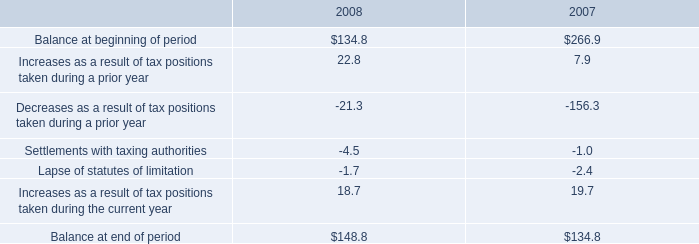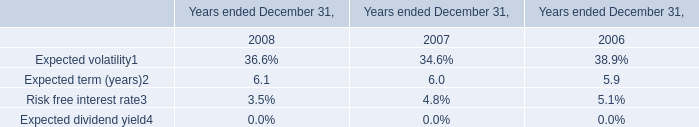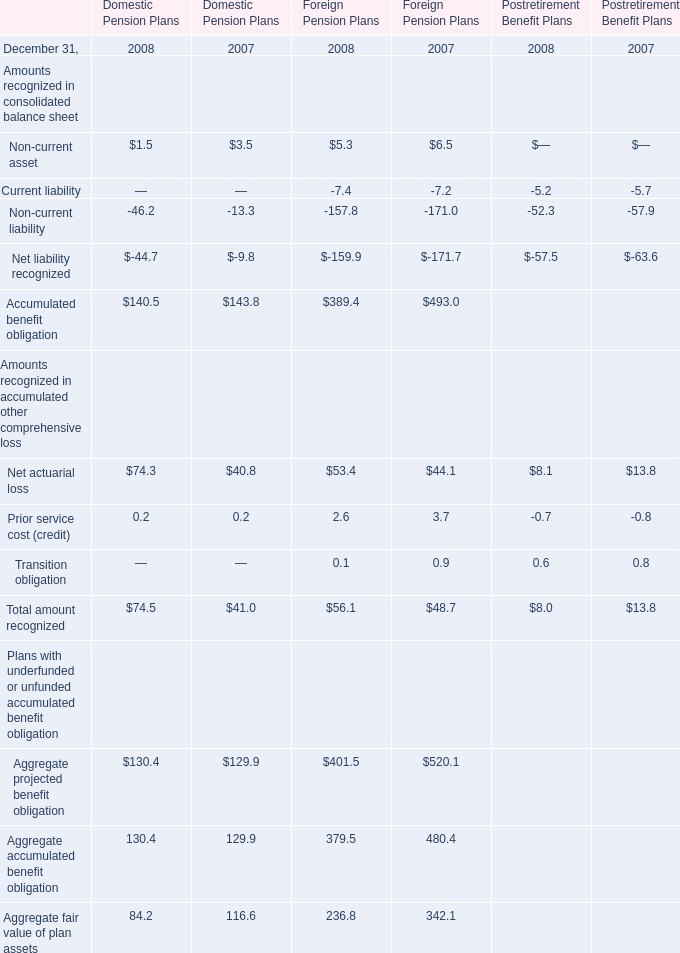what percentage of balance of unrecognized tax benefits at the end of 2008 would impact the effective tax rate if recognized? 
Computations: (131.8 / 148.8)
Answer: 0.88575. 